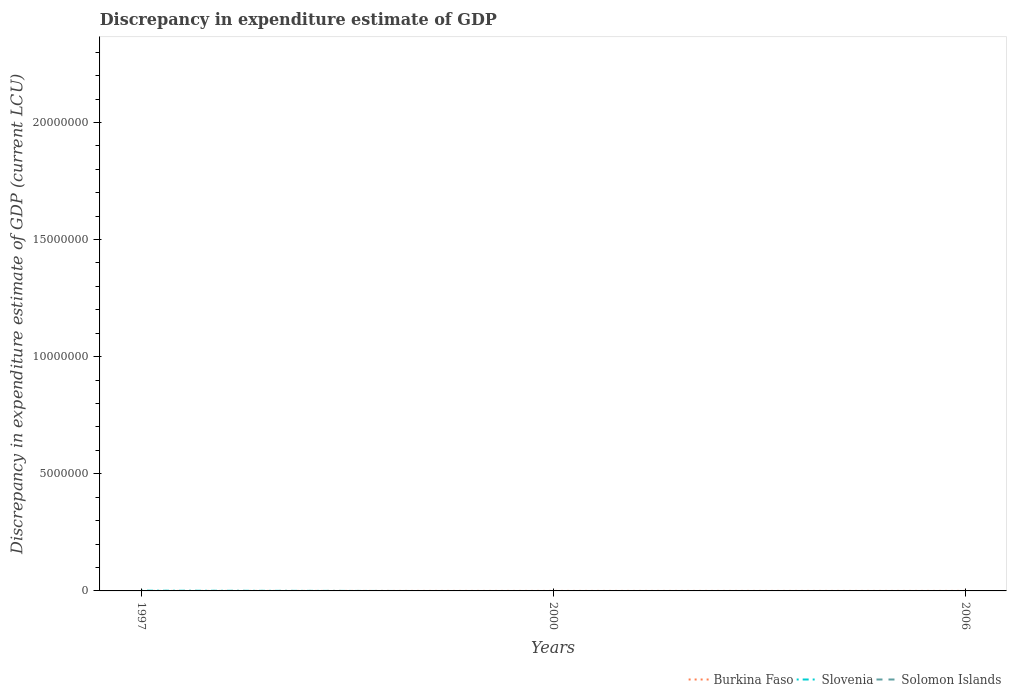How many different coloured lines are there?
Keep it short and to the point. 2. Does the line corresponding to Burkina Faso intersect with the line corresponding to Slovenia?
Your answer should be compact. Yes. Is the number of lines equal to the number of legend labels?
Ensure brevity in your answer.  No. Across all years, what is the maximum discrepancy in expenditure estimate of GDP in Solomon Islands?
Ensure brevity in your answer.  0. What is the total discrepancy in expenditure estimate of GDP in Burkina Faso in the graph?
Make the answer very short. 3e-5. What is the difference between the highest and the second highest discrepancy in expenditure estimate of GDP in Burkina Faso?
Offer a terse response. 6e-5. How many lines are there?
Your answer should be compact. 2. What is the difference between two consecutive major ticks on the Y-axis?
Give a very brief answer. 5.00e+06. Are the values on the major ticks of Y-axis written in scientific E-notation?
Offer a terse response. No. Does the graph contain any zero values?
Provide a short and direct response. Yes. Does the graph contain grids?
Give a very brief answer. No. How many legend labels are there?
Keep it short and to the point. 3. What is the title of the graph?
Keep it short and to the point. Discrepancy in expenditure estimate of GDP. What is the label or title of the Y-axis?
Your answer should be very brief. Discrepancy in expenditure estimate of GDP (current LCU). What is the Discrepancy in expenditure estimate of GDP (current LCU) in Burkina Faso in 1997?
Your answer should be very brief. 6e-5. What is the Discrepancy in expenditure estimate of GDP (current LCU) of Slovenia in 1997?
Make the answer very short. 10000. What is the Discrepancy in expenditure estimate of GDP (current LCU) in Solomon Islands in 1997?
Your response must be concise. 0. What is the Discrepancy in expenditure estimate of GDP (current LCU) in Burkina Faso in 2000?
Make the answer very short. 3e-5. Across all years, what is the maximum Discrepancy in expenditure estimate of GDP (current LCU) in Burkina Faso?
Ensure brevity in your answer.  6e-5. Across all years, what is the maximum Discrepancy in expenditure estimate of GDP (current LCU) in Slovenia?
Offer a terse response. 10000. What is the difference between the Discrepancy in expenditure estimate of GDP (current LCU) of Burkina Faso in 1997 and that in 2000?
Ensure brevity in your answer.  0. What is the average Discrepancy in expenditure estimate of GDP (current LCU) in Burkina Faso per year?
Offer a very short reply. 0. What is the average Discrepancy in expenditure estimate of GDP (current LCU) in Slovenia per year?
Provide a short and direct response. 3333.33. What is the average Discrepancy in expenditure estimate of GDP (current LCU) in Solomon Islands per year?
Your response must be concise. 0. In the year 1997, what is the difference between the Discrepancy in expenditure estimate of GDP (current LCU) in Burkina Faso and Discrepancy in expenditure estimate of GDP (current LCU) in Slovenia?
Ensure brevity in your answer.  -10000. What is the difference between the highest and the lowest Discrepancy in expenditure estimate of GDP (current LCU) in Slovenia?
Give a very brief answer. 10000. 